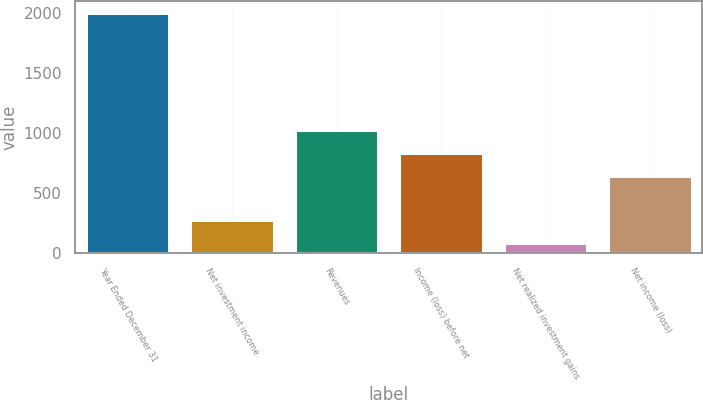Convert chart to OTSL. <chart><loc_0><loc_0><loc_500><loc_500><bar_chart><fcel>Year Ended December 31<fcel>Net investment income<fcel>Revenues<fcel>Income (loss) before net<fcel>Net realized investment gains<fcel>Net income (loss)<nl><fcel>2003<fcel>277.25<fcel>1028<fcel>836.25<fcel>85.5<fcel>644.5<nl></chart> 